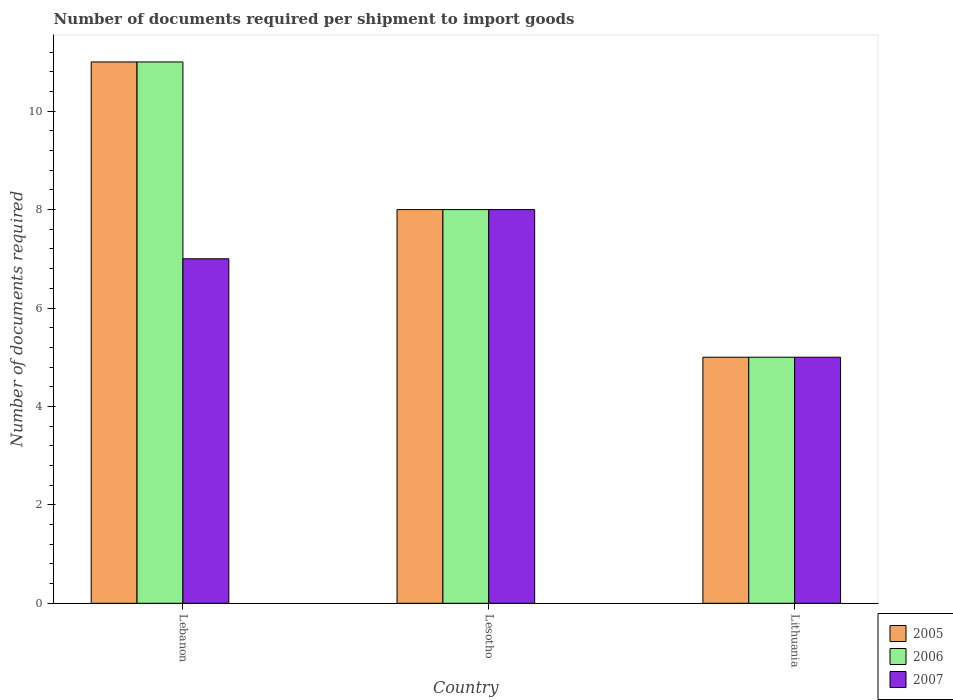How many different coloured bars are there?
Give a very brief answer. 3. How many groups of bars are there?
Offer a very short reply. 3. Are the number of bars on each tick of the X-axis equal?
Your answer should be very brief. Yes. How many bars are there on the 1st tick from the right?
Give a very brief answer. 3. What is the label of the 1st group of bars from the left?
Your answer should be compact. Lebanon. What is the number of documents required per shipment to import goods in 2006 in Lithuania?
Ensure brevity in your answer.  5. Across all countries, what is the minimum number of documents required per shipment to import goods in 2005?
Ensure brevity in your answer.  5. In which country was the number of documents required per shipment to import goods in 2007 maximum?
Make the answer very short. Lesotho. In which country was the number of documents required per shipment to import goods in 2006 minimum?
Make the answer very short. Lithuania. What is the total number of documents required per shipment to import goods in 2007 in the graph?
Provide a succinct answer. 20. What is the difference between the number of documents required per shipment to import goods in 2007 in Lebanon and that in Lesotho?
Offer a terse response. -1. What is the difference between the number of documents required per shipment to import goods of/in 2007 and number of documents required per shipment to import goods of/in 2006 in Lebanon?
Make the answer very short. -4. What is the ratio of the number of documents required per shipment to import goods in 2006 in Lesotho to that in Lithuania?
Your answer should be compact. 1.6. Is the number of documents required per shipment to import goods in 2007 in Lebanon less than that in Lesotho?
Make the answer very short. Yes. Is the difference between the number of documents required per shipment to import goods in 2007 in Lebanon and Lesotho greater than the difference between the number of documents required per shipment to import goods in 2006 in Lebanon and Lesotho?
Provide a succinct answer. No. What is the difference between the highest and the second highest number of documents required per shipment to import goods in 2006?
Your answer should be very brief. -3. What is the difference between the highest and the lowest number of documents required per shipment to import goods in 2005?
Make the answer very short. 6. Is the sum of the number of documents required per shipment to import goods in 2006 in Lebanon and Lithuania greater than the maximum number of documents required per shipment to import goods in 2007 across all countries?
Ensure brevity in your answer.  Yes. What does the 2nd bar from the left in Lesotho represents?
Offer a very short reply. 2006. What does the 1st bar from the right in Lithuania represents?
Your answer should be very brief. 2007. Is it the case that in every country, the sum of the number of documents required per shipment to import goods in 2006 and number of documents required per shipment to import goods in 2007 is greater than the number of documents required per shipment to import goods in 2005?
Provide a short and direct response. Yes. How many bars are there?
Offer a very short reply. 9. What is the difference between two consecutive major ticks on the Y-axis?
Give a very brief answer. 2. Does the graph contain grids?
Give a very brief answer. No. Where does the legend appear in the graph?
Ensure brevity in your answer.  Bottom right. What is the title of the graph?
Make the answer very short. Number of documents required per shipment to import goods. Does "2000" appear as one of the legend labels in the graph?
Offer a very short reply. No. What is the label or title of the X-axis?
Your answer should be very brief. Country. What is the label or title of the Y-axis?
Make the answer very short. Number of documents required. What is the Number of documents required of 2007 in Lebanon?
Provide a succinct answer. 7. What is the Number of documents required in 2005 in Lesotho?
Offer a very short reply. 8. What is the Number of documents required of 2006 in Lithuania?
Your answer should be very brief. 5. Across all countries, what is the maximum Number of documents required of 2005?
Offer a terse response. 11. Across all countries, what is the maximum Number of documents required in 2006?
Provide a short and direct response. 11. Across all countries, what is the maximum Number of documents required in 2007?
Offer a very short reply. 8. Across all countries, what is the minimum Number of documents required in 2006?
Your answer should be compact. 5. Across all countries, what is the minimum Number of documents required of 2007?
Your answer should be compact. 5. What is the total Number of documents required of 2006 in the graph?
Make the answer very short. 24. What is the difference between the Number of documents required of 2005 in Lebanon and that in Lesotho?
Your response must be concise. 3. What is the difference between the Number of documents required of 2006 in Lebanon and that in Lesotho?
Provide a succinct answer. 3. What is the difference between the Number of documents required in 2007 in Lebanon and that in Lesotho?
Keep it short and to the point. -1. What is the difference between the Number of documents required of 2006 in Lebanon and that in Lithuania?
Your response must be concise. 6. What is the difference between the Number of documents required in 2006 in Lesotho and that in Lithuania?
Provide a succinct answer. 3. What is the difference between the Number of documents required in 2007 in Lesotho and that in Lithuania?
Keep it short and to the point. 3. What is the difference between the Number of documents required in 2005 in Lesotho and the Number of documents required in 2007 in Lithuania?
Keep it short and to the point. 3. What is the difference between the Number of documents required of 2006 in Lesotho and the Number of documents required of 2007 in Lithuania?
Your answer should be very brief. 3. What is the difference between the Number of documents required of 2005 and Number of documents required of 2007 in Lebanon?
Give a very brief answer. 4. What is the difference between the Number of documents required of 2005 and Number of documents required of 2007 in Lesotho?
Provide a short and direct response. 0. What is the difference between the Number of documents required in 2005 and Number of documents required in 2007 in Lithuania?
Ensure brevity in your answer.  0. What is the difference between the Number of documents required of 2006 and Number of documents required of 2007 in Lithuania?
Your answer should be very brief. 0. What is the ratio of the Number of documents required in 2005 in Lebanon to that in Lesotho?
Your response must be concise. 1.38. What is the ratio of the Number of documents required in 2006 in Lebanon to that in Lesotho?
Offer a very short reply. 1.38. What is the ratio of the Number of documents required of 2005 in Lebanon to that in Lithuania?
Your answer should be compact. 2.2. What is the ratio of the Number of documents required in 2007 in Lebanon to that in Lithuania?
Offer a terse response. 1.4. What is the difference between the highest and the second highest Number of documents required in 2006?
Give a very brief answer. 3. What is the difference between the highest and the lowest Number of documents required of 2006?
Your response must be concise. 6. What is the difference between the highest and the lowest Number of documents required in 2007?
Offer a very short reply. 3. 